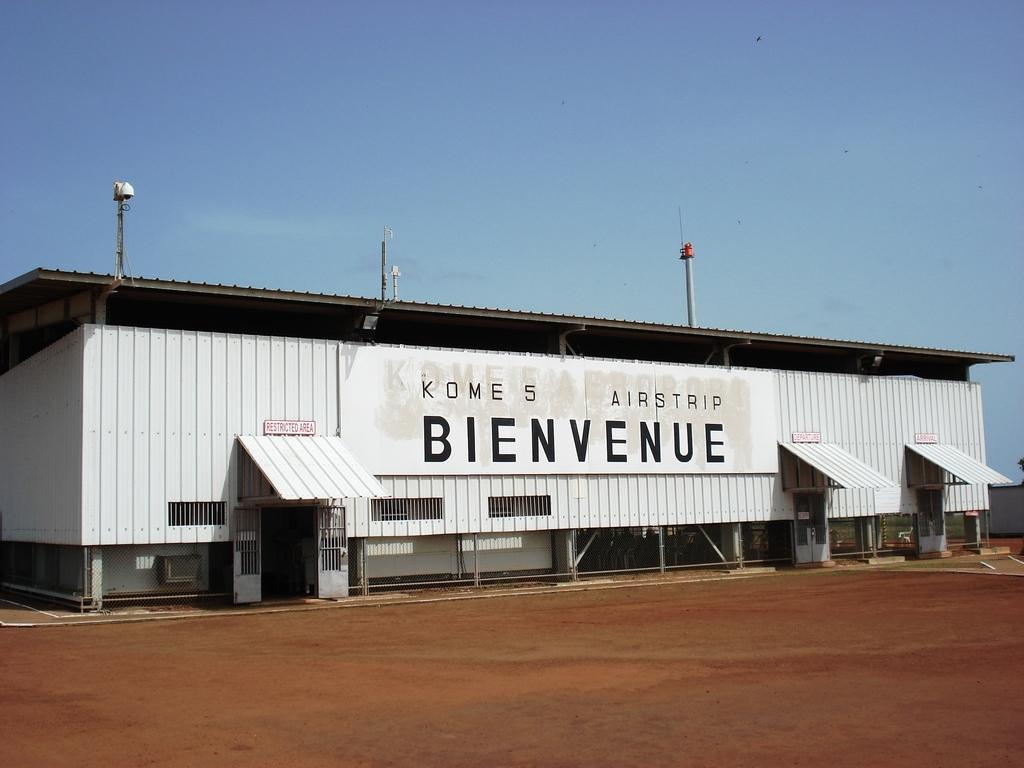What structure is present in the image? There is a shed in the image. What is the color of the shed? The shed is white in color. What features can be seen on the shed? There are poles and doors on the shed. What is visible at the top of the image? The sky is visible at the top of the image. What is visible at the bottom of the image? The ground is visible at the bottom of the image. Where is the cabbage placed in the image? There is no cabbage present in the image. What type of button can be seen on the sofa in the image? There is no sofa or button present in the image. 